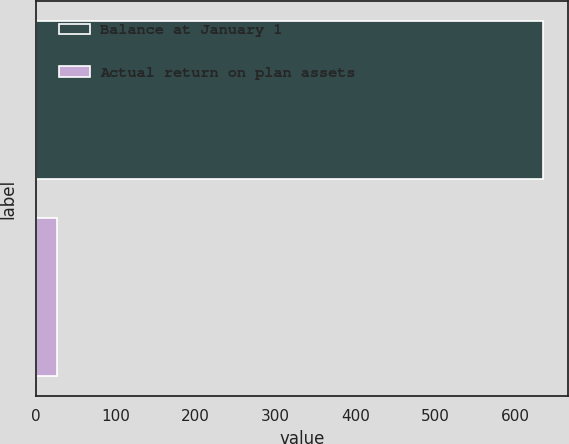Convert chart. <chart><loc_0><loc_0><loc_500><loc_500><bar_chart><fcel>Balance at January 1<fcel>Actual return on plan assets<nl><fcel>635<fcel>26<nl></chart> 